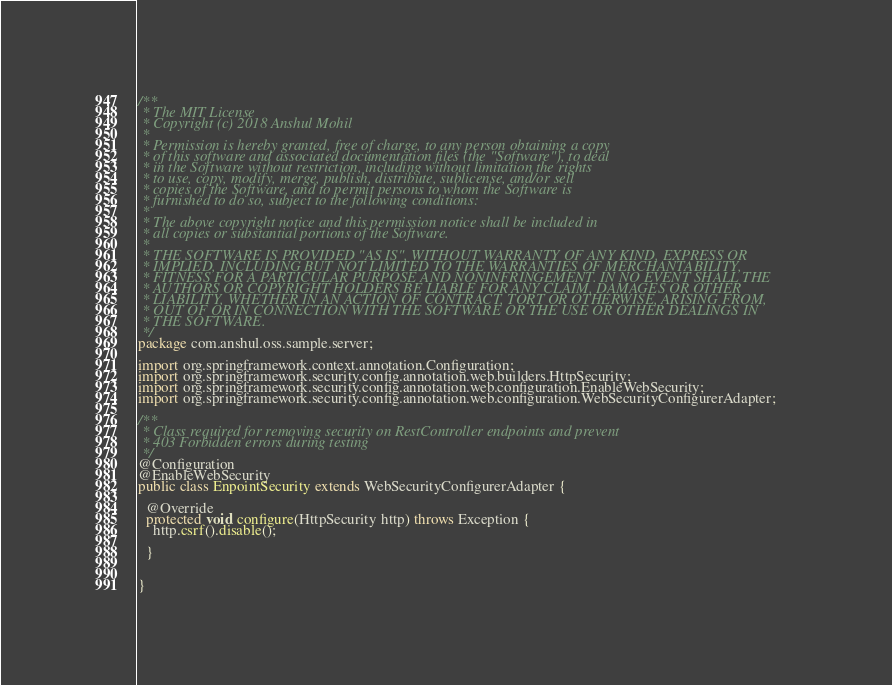<code> <loc_0><loc_0><loc_500><loc_500><_Java_>/**
 * The MIT License
 * Copyright (c) 2018 Anshul Mohil
 *
 * Permission is hereby granted, free of charge, to any person obtaining a copy
 * of this software and associated documentation files (the "Software"), to deal
 * in the Software without restriction, including without limitation the rights
 * to use, copy, modify, merge, publish, distribute, sublicense, and/or sell
 * copies of the Software, and to permit persons to whom the Software is
 * furnished to do so, subject to the following conditions:
 *
 * The above copyright notice and this permission notice shall be included in
 * all copies or substantial portions of the Software.
 *
 * THE SOFTWARE IS PROVIDED "AS IS", WITHOUT WARRANTY OF ANY KIND, EXPRESS OR
 * IMPLIED, INCLUDING BUT NOT LIMITED TO THE WARRANTIES OF MERCHANTABILITY,
 * FITNESS FOR A PARTICULAR PURPOSE AND NONINFRINGEMENT. IN NO EVENT SHALL THE
 * AUTHORS OR COPYRIGHT HOLDERS BE LIABLE FOR ANY CLAIM, DAMAGES OR OTHER
 * LIABILITY, WHETHER IN AN ACTION OF CONTRACT, TORT OR OTHERWISE, ARISING FROM,
 * OUT OF OR IN CONNECTION WITH THE SOFTWARE OR THE USE OR OTHER DEALINGS IN
 * THE SOFTWARE.
 */
package com.anshul.oss.sample.server;

import org.springframework.context.annotation.Configuration;
import org.springframework.security.config.annotation.web.builders.HttpSecurity;
import org.springframework.security.config.annotation.web.configuration.EnableWebSecurity;
import org.springframework.security.config.annotation.web.configuration.WebSecurityConfigurerAdapter;

/**
 * Class required for removing security on RestController endpoints and prevent
 * 403 Forbidden errors during testing
 */
@Configuration
@EnableWebSecurity
public class EnpointSecurity extends WebSecurityConfigurerAdapter {

  @Override
  protected void configure(HttpSecurity http) throws Exception {
    http.csrf().disable();

  }


}</code> 